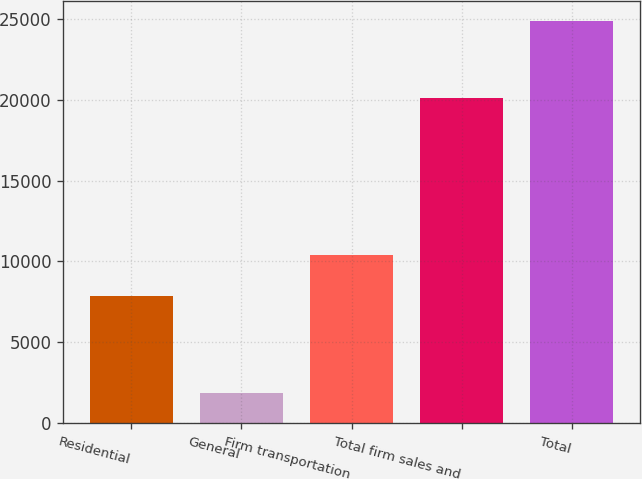Convert chart. <chart><loc_0><loc_0><loc_500><loc_500><bar_chart><fcel>Residential<fcel>General<fcel>Firm transportation<fcel>Total firm sales and<fcel>Total<nl><fcel>7872<fcel>1851<fcel>10381<fcel>20104<fcel>24842<nl></chart> 